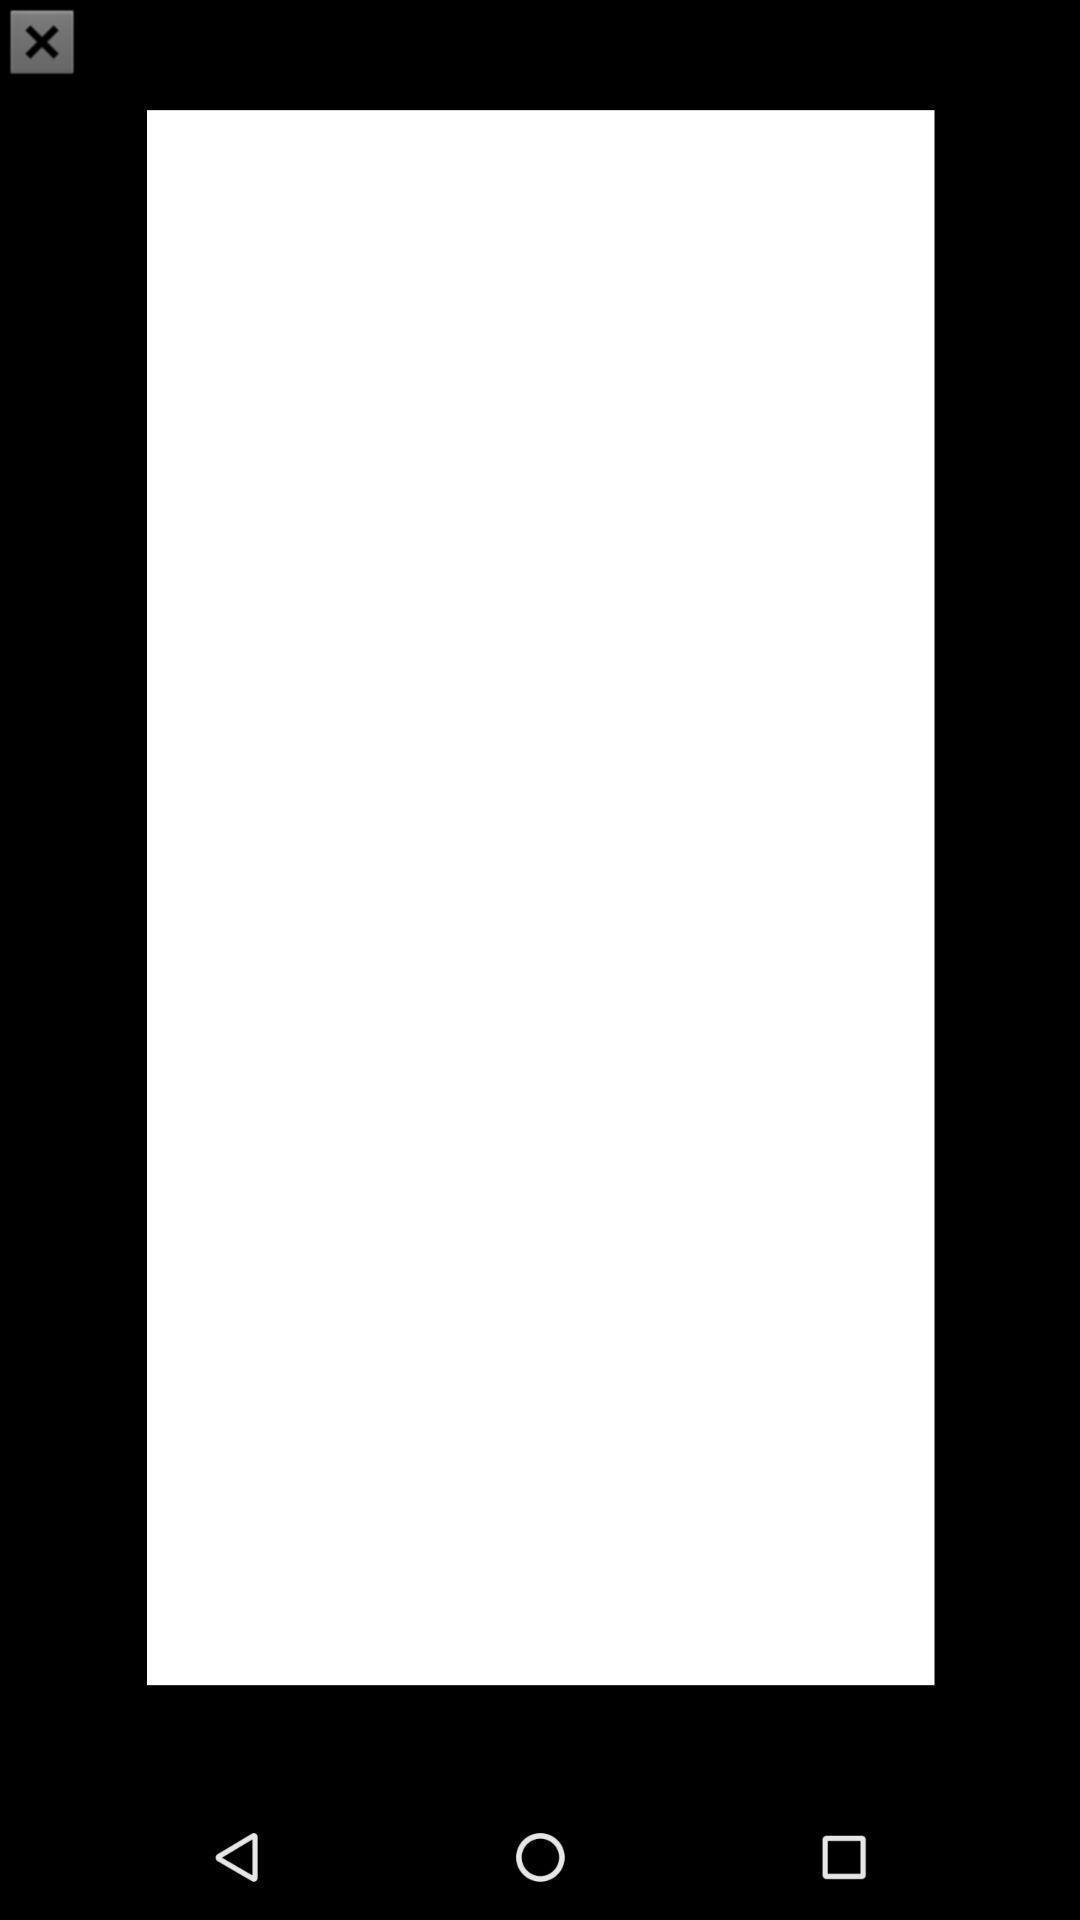Give me a summary of this screen capture. Screen shows pop up. 